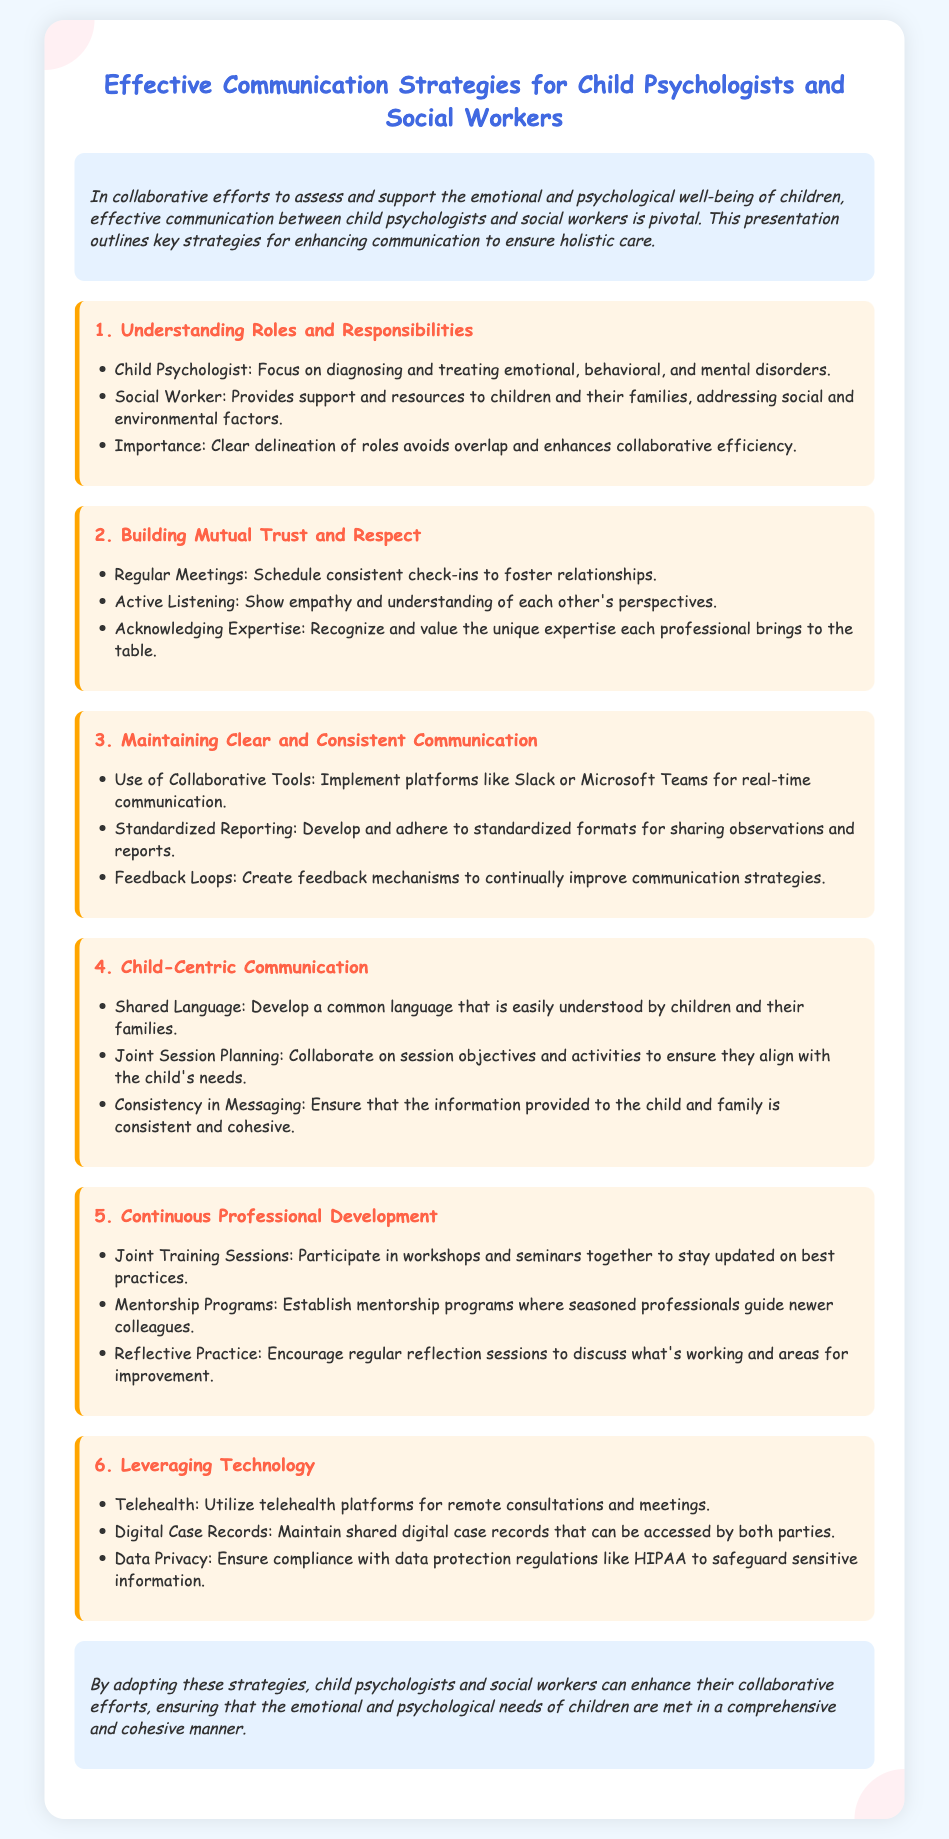What is the title of the presentation? The title is stated at the top of the document and describes the main focus of the content.
Answer: Effective Communication Strategies for Child Psychologists and Social Workers What is the first section about? The first section outlines the roles and responsibilities of child psychologists and social workers, as stated in the document.
Answer: Understanding Roles and Responsibilities Name one strategy to build mutual trust and respect. The document lists specific strategies under each section, and one is mentioned here as an example.
Answer: Regular Meetings What is one tool suggested for maintaining clear communication? The document suggests the use of collaborative tools, which are listed in the section about communication.
Answer: Slack or Microsoft Teams How many strategies are listed under child-centric communication? The document specifies the number of strategies provided in this section, which directly answers the question.
Answer: Three What is emphasized for continuous professional development? The document highlights joint training sessions as a key element in this section for professional growth.
Answer: Joint Training Sessions What type of platform is suggested for remote consultations? The document specifically suggests utilizing telehealth platforms for remote interactions.
Answer: Telehealth What do child psychologists focus on? The document clearly states the primary focus of child psychologists in the roles section.
Answer: Diagnosing and treating emotional, behavioral, and mental disorders 